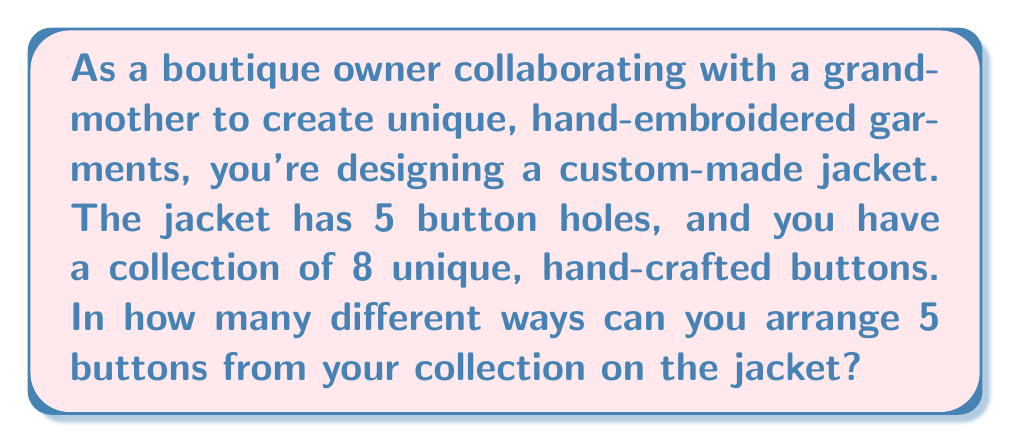What is the answer to this math problem? To solve this problem, we need to use the concept of permutations. We are selecting 5 buttons out of 8 and arranging them in a specific order on the jacket.

1. This is a permutation problem because:
   - The order matters (each button position is distinct)
   - We are selecting a subset of the total buttons (5 out of 8)

2. The formula for permutations is:

   $$P(n,r) = \frac{n!}{(n-r)!}$$

   Where $n$ is the total number of items to choose from, and $r$ is the number of items being chosen.

3. In this case:
   $n = 8$ (total number of unique buttons)
   $r = 5$ (number of buttons needed for the jacket)

4. Plugging these values into the formula:

   $$P(8,5) = \frac{8!}{(8-5)!} = \frac{8!}{3!}$$

5. Expanding this:
   
   $$\frac{8 \times 7 \times 6 \times 5 \times 4 \times 3!}{3!}$$

6. The $3!$ cancels out in the numerator and denominator:

   $$8 \times 7 \times 6 \times 5 \times 4 = 6720$$

Therefore, there are 6720 different ways to arrange 5 buttons from the collection of 8 on the custom-made jacket.
Answer: 6720 